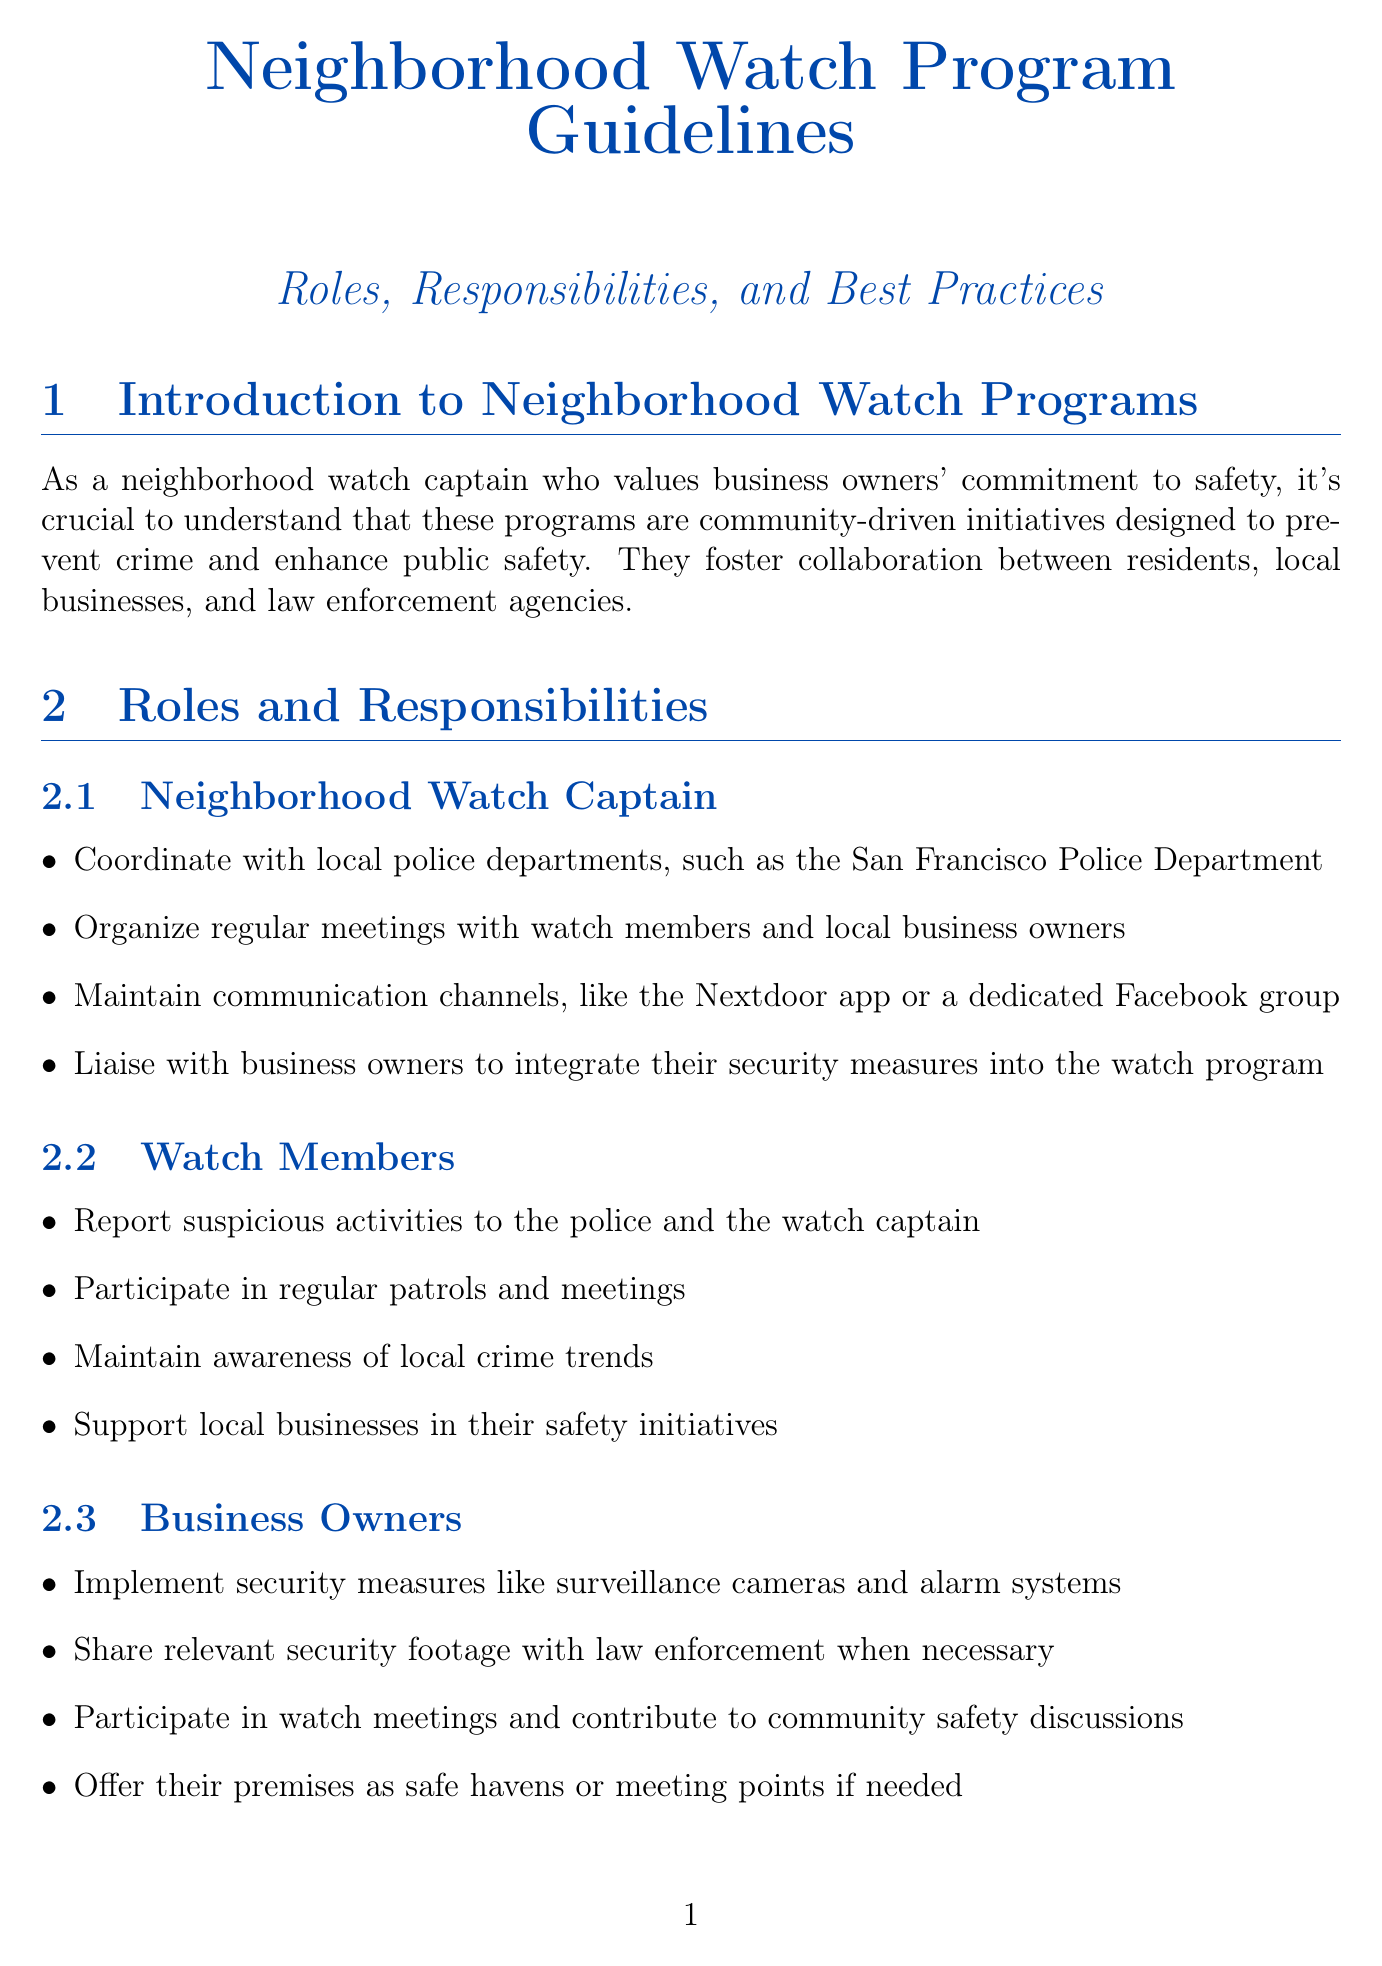What is the primary purpose of Neighborhood Watch Programs? The primary purpose is to prevent crime and enhance public safety through collaboration between residents, businesses, and law enforcement.
Answer: prevent crime and enhance public safety Who coordinates with local police departments? The Neighborhood Watch Captain is responsible for coordinating with local police departments.
Answer: Neighborhood Watch Captain What security measures should business owners implement? Business owners are advised to implement security measures like surveillance cameras and alarm systems.
Answer: surveillance cameras and alarm systems What is one recommended best practice for communication? Establishing clear communication protocols using tools like WhatsApp or Signal is recommended.
Answer: WhatsApp or Signal What type of training is organized with the American Red Cross? CPR and first aid training is conducted with the American Red Cross.
Answer: CPR and first aid training How should suspicious activities be reported? Suspicious activities should be reported to the police and the watch captain.
Answer: to the police and the watch captain What is a method to measure the program's success? Tracking crime statistics before and after program implementation is a method to measure success.
Answer: track crime statistics What type of program could be created within the neighborhood watch for business owners? A business watch subcommittee can be created within the neighborhood watch for business owners.
Answer: business watch subcommittee 